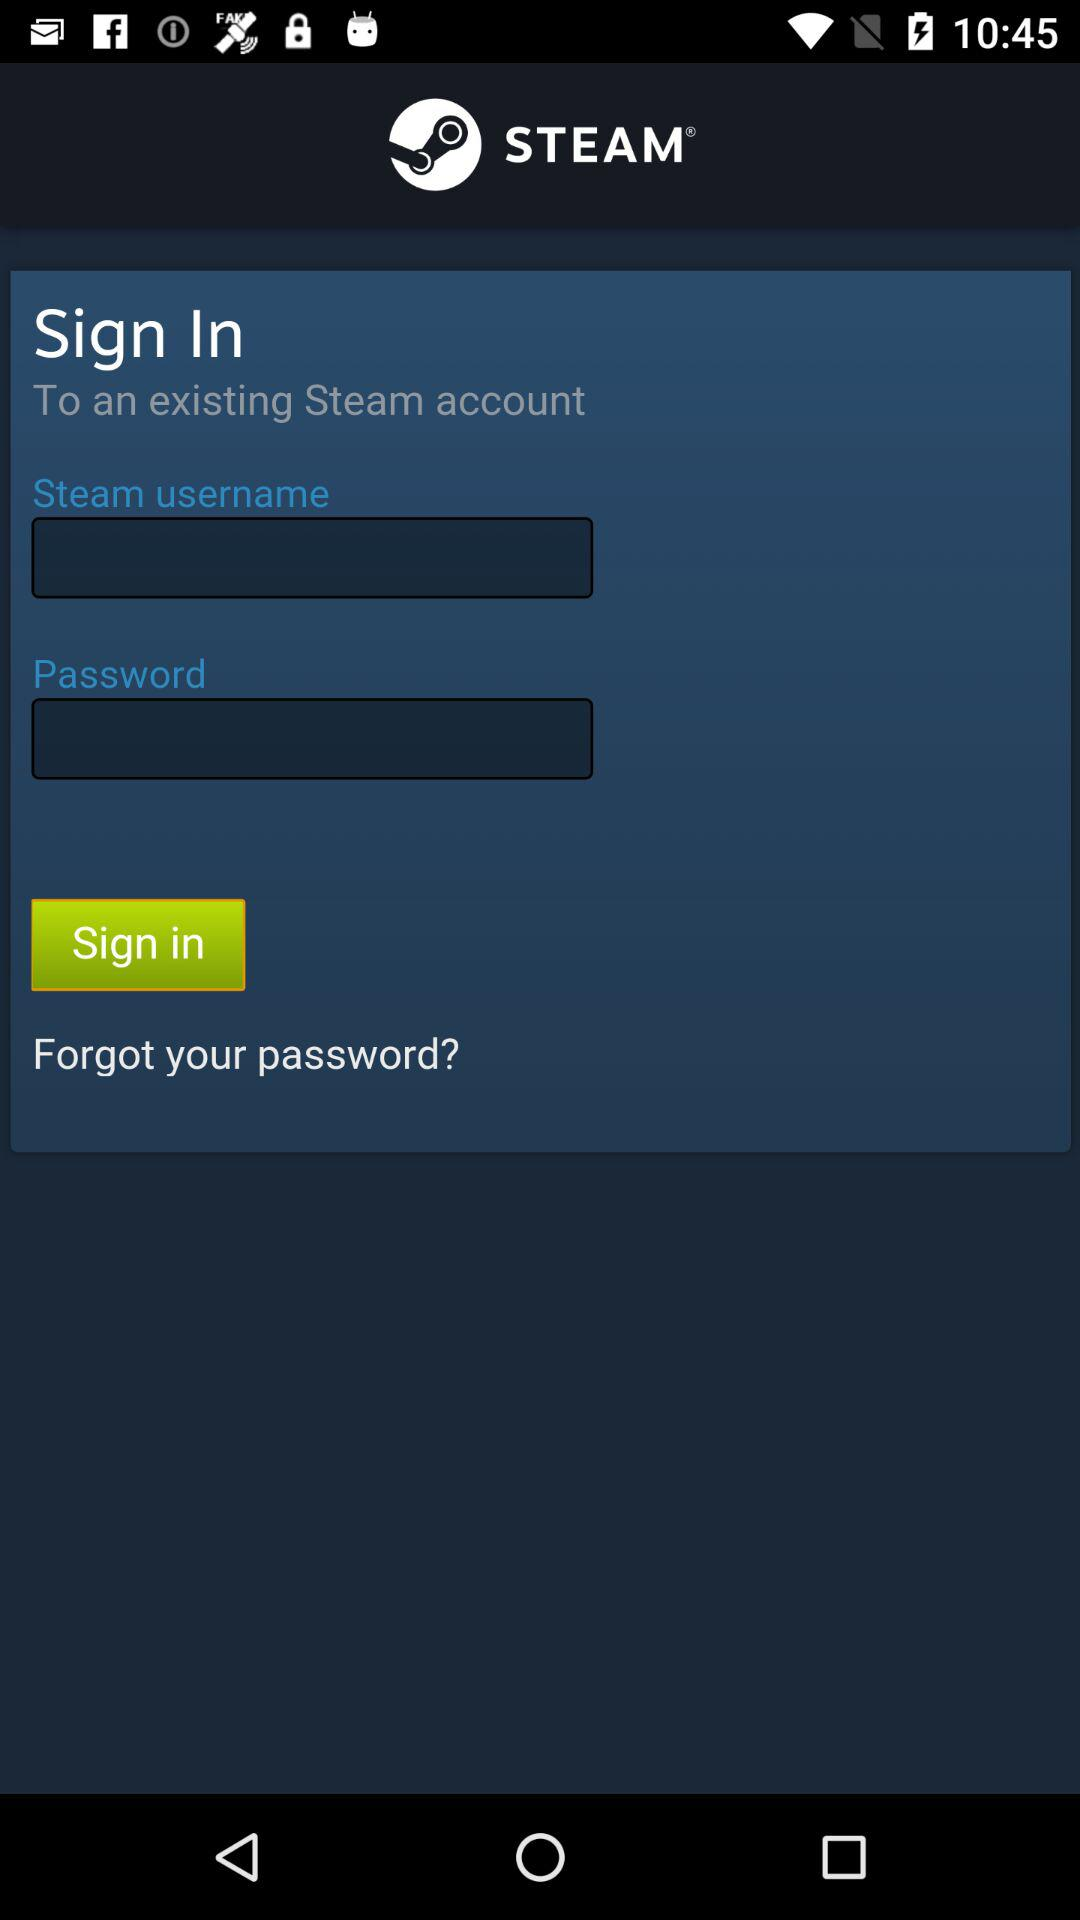What is the application name? The application name is "STEAM". 